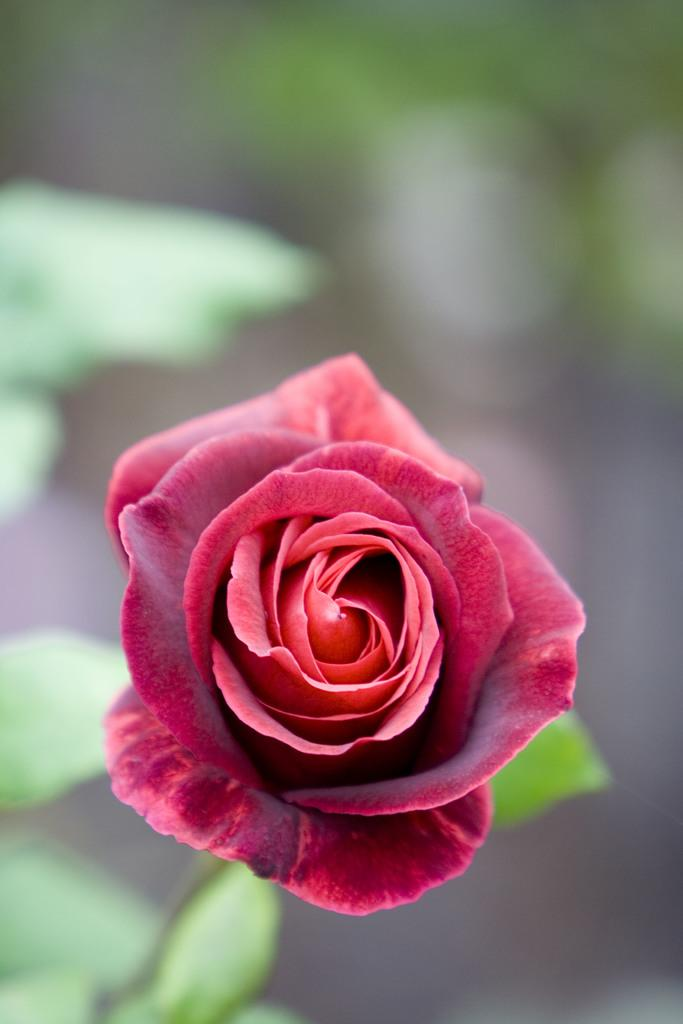What can be observed about the background of the image? The background portion of the picture is blurry. What type of flower is present in the image? There is a red rose in the image. Are there any other plants visible besides the red rose? Yes, there are green leaves in the image. What type of toy can be seen in the image? There are no toys present in the image; it features a red rose and green leaves. How many oranges are visible in the image? There are no oranges present in the image. 